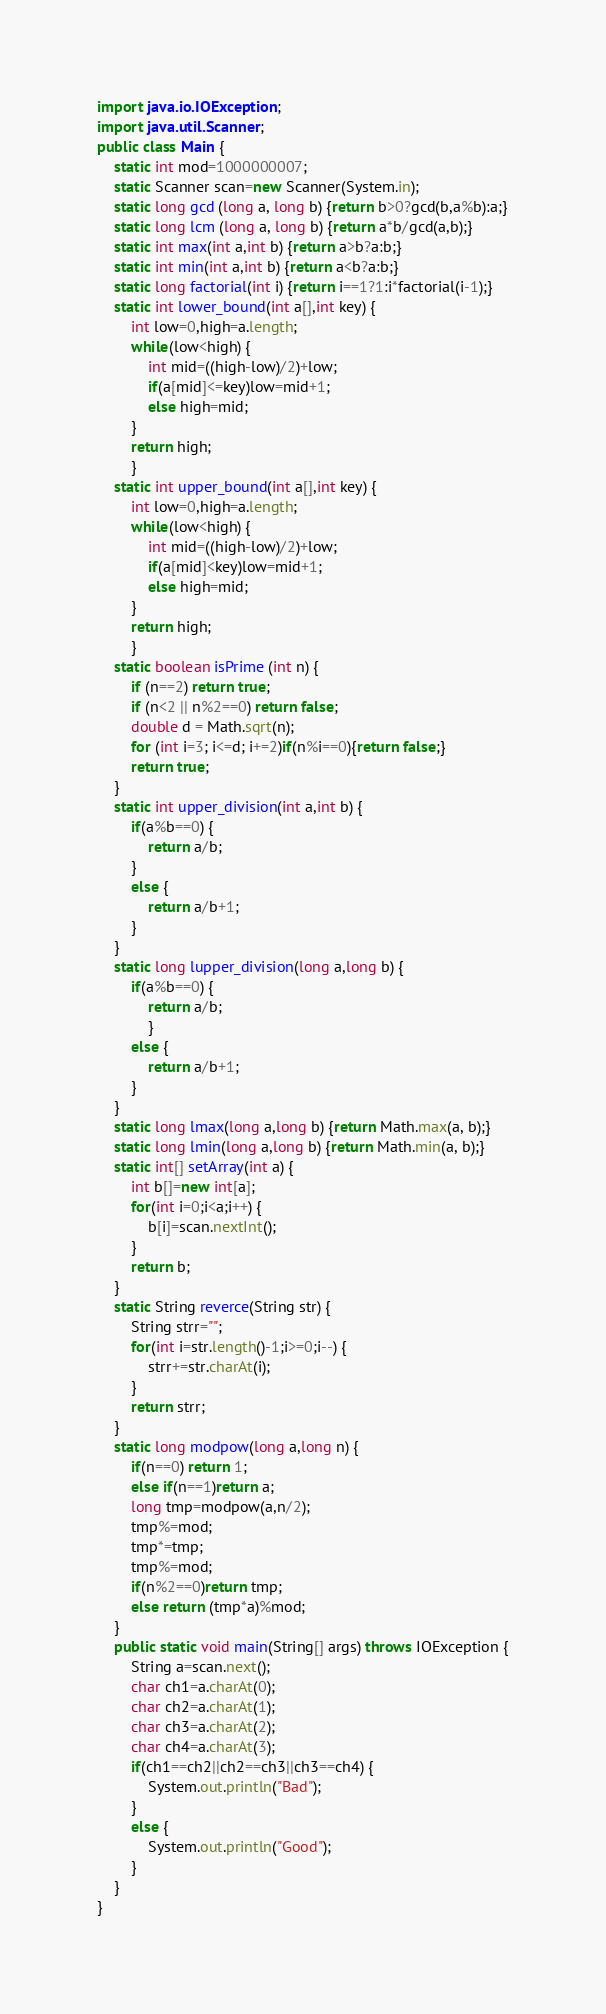Convert code to text. <code><loc_0><loc_0><loc_500><loc_500><_Java_>import java.io.IOException;
import java.util.Scanner;
public class Main {
	static int mod=1000000007;
	static Scanner scan=new Scanner(System.in);
	static long gcd (long a, long b) {return b>0?gcd(b,a%b):a;}
	static long lcm (long a, long b) {return a*b/gcd(a,b);}
	static int max(int a,int b) {return a>b?a:b;}
	static int min(int a,int b) {return a<b?a:b;}
	static long factorial(int i) {return i==1?1:i*factorial(i-1);}
	static int lower_bound(int a[],int key) {
		int low=0,high=a.length;
		while(low<high) {
			int mid=((high-low)/2)+low;
			if(a[mid]<=key)low=mid+1;
			else high=mid;
		}
		return high;
		}
	static int upper_bound(int a[],int key) {
		int low=0,high=a.length;
		while(low<high) {
			int mid=((high-low)/2)+low;
			if(a[mid]<key)low=mid+1;
			else high=mid;
		}
		return high;
		}
	static boolean isPrime (int n) {
		if (n==2) return true;
		if (n<2 || n%2==0) return false;
		double d = Math.sqrt(n);
		for (int i=3; i<=d; i+=2)if(n%i==0){return false;}
		return true;
	}
	static int upper_division(int a,int b) {
		if(a%b==0) {
			return a/b;
		}
		else {
			return a/b+1;
		}
	}
	static long lupper_division(long a,long b) {
		if(a%b==0) {
			return a/b;
			}
		else {
			return a/b+1;
		}
	}
	static long lmax(long a,long b) {return Math.max(a, b);}
	static long lmin(long a,long b) {return Math.min(a, b);}
	static int[] setArray(int a) {
		int b[]=new int[a];
		for(int i=0;i<a;i++) {
			b[i]=scan.nextInt();
		}
		return b;
	}
	static String reverce(String str) {
		String strr="";
		for(int i=str.length()-1;i>=0;i--) {
			strr+=str.charAt(i);
		}
		return strr;
	}
	static long modpow(long a,long n) {
		if(n==0) return 1;
		else if(n==1)return a;
		long tmp=modpow(a,n/2);
		tmp%=mod;
		tmp*=tmp;
		tmp%=mod;
		if(n%2==0)return tmp;
		else return (tmp*a)%mod;
	}
	public static void main(String[] args) throws IOException {
		String a=scan.next();
		char ch1=a.charAt(0);
		char ch2=a.charAt(1);
		char ch3=a.charAt(2);
		char ch4=a.charAt(3);
		if(ch1==ch2||ch2==ch3||ch3==ch4) {
			System.out.println("Bad");
		}
		else {
			System.out.println("Good");
		}
	}
}
</code> 